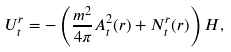<formula> <loc_0><loc_0><loc_500><loc_500>U ^ { r } _ { t } = - \left ( \frac { m ^ { 2 } } { 4 \pi } A _ { t } ^ { 2 } ( r ) + N ^ { r } _ { t } ( r ) \right ) H ,</formula> 